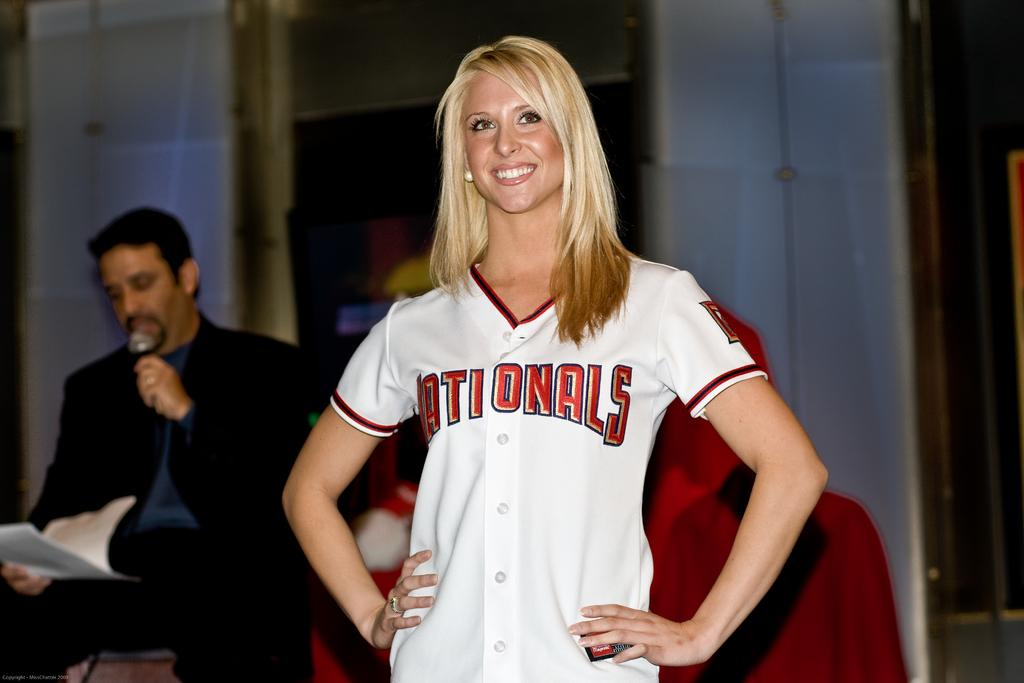<image>
Create a compact narrative representing the image presented. A girl wearing a Nationals jersey stands in front of a man holding a microphone 